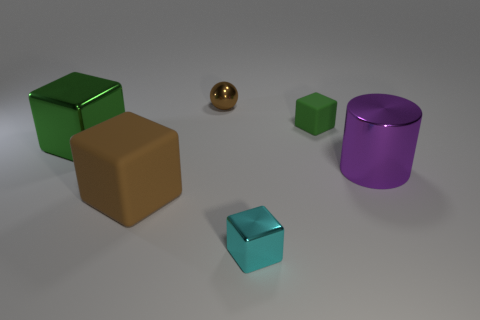Subtract all large rubber cubes. How many cubes are left? 3 Subtract all blue cylinders. How many green cubes are left? 2 Add 4 red shiny things. How many objects exist? 10 Subtract all brown blocks. How many blocks are left? 3 Subtract all cylinders. How many objects are left? 5 Subtract all gray spheres. Subtract all yellow blocks. How many spheres are left? 1 Subtract all brown matte things. Subtract all big purple cylinders. How many objects are left? 4 Add 1 large purple objects. How many large purple objects are left? 2 Add 3 brown cubes. How many brown cubes exist? 4 Subtract 0 blue cubes. How many objects are left? 6 